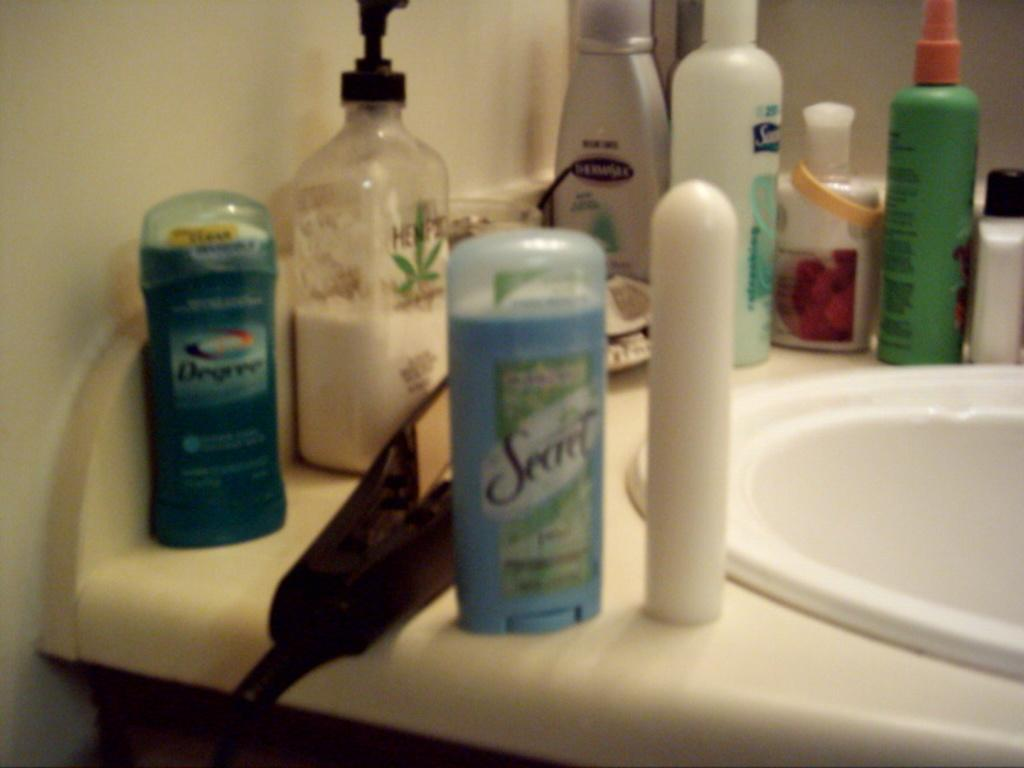<image>
Provide a brief description of the given image. Secret deodorant and Degree deodorant are among several items around a bathroom sink. 